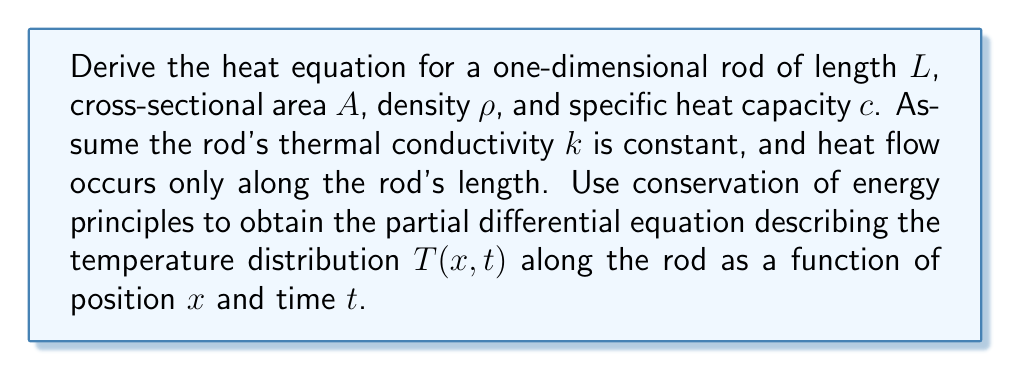Provide a solution to this math problem. Let's derive the heat equation step-by-step using conservation of energy:

1) Consider a small segment of the rod from $x$ to $x + \Delta x$.

2) The rate of change of thermal energy in this segment is:
   $$\frac{\partial E}{\partial t} = \rho c A \Delta x \frac{\partial T}{\partial t}$$

3) The heat flux (energy per unit time per unit area) is given by Fourier's law:
   $$q = -k \frac{\partial T}{\partial x}$$

4) The net rate of heat flow into the segment is the difference between the heat entering at $x$ and leaving at $x + \Delta x$:
   $$Q_{net} = \left[q(x) - q(x+\Delta x)\right]A$$

5) Expanding $q(x+\Delta x)$ using Taylor series:
   $$Q_{net} = \left[q(x) - \left(q(x) + \frac{\partial q}{\partial x}\Delta x\right)\right]A = -A\frac{\partial q}{\partial x}\Delta x$$

6) Substituting Fourier's law:
   $$Q_{net} = -A\frac{\partial}{\partial x}\left(-k\frac{\partial T}{\partial x}\right)\Delta x = kA\frac{\partial^2 T}{\partial x^2}\Delta x$$

7) By conservation of energy, the rate of change of thermal energy equals the net heat flow:
   $$\rho c A \Delta x \frac{\partial T}{\partial t} = kA\frac{\partial^2 T}{\partial x^2}\Delta x$$

8) Simplifying:
   $$\rho c \frac{\partial T}{\partial t} = k\frac{\partial^2 T}{\partial x^2}$$

9) Define the thermal diffusivity $\alpha = \frac{k}{\rho c}$, then:
   $$\frac{\partial T}{\partial t} = \alpha\frac{\partial^2 T}{\partial x^2}$$

This is the one-dimensional heat equation.
Answer: $$\frac{\partial T}{\partial t} = \alpha\frac{\partial^2 T}{\partial x^2}$$ 